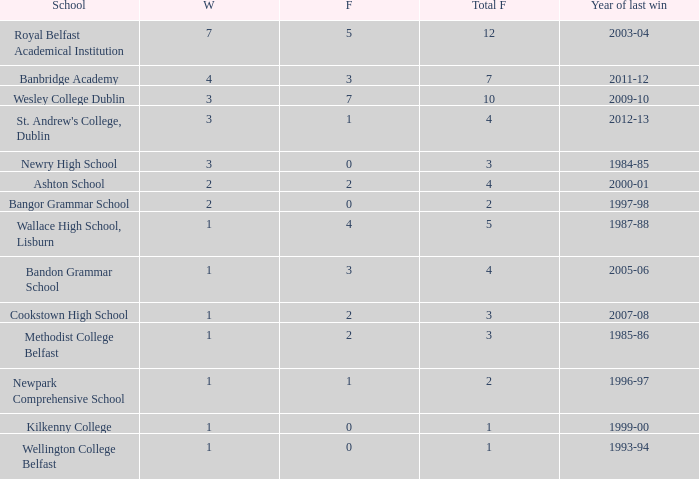What are the names that had a finalist score of 2? Ashton School, Cookstown High School, Methodist College Belfast. 